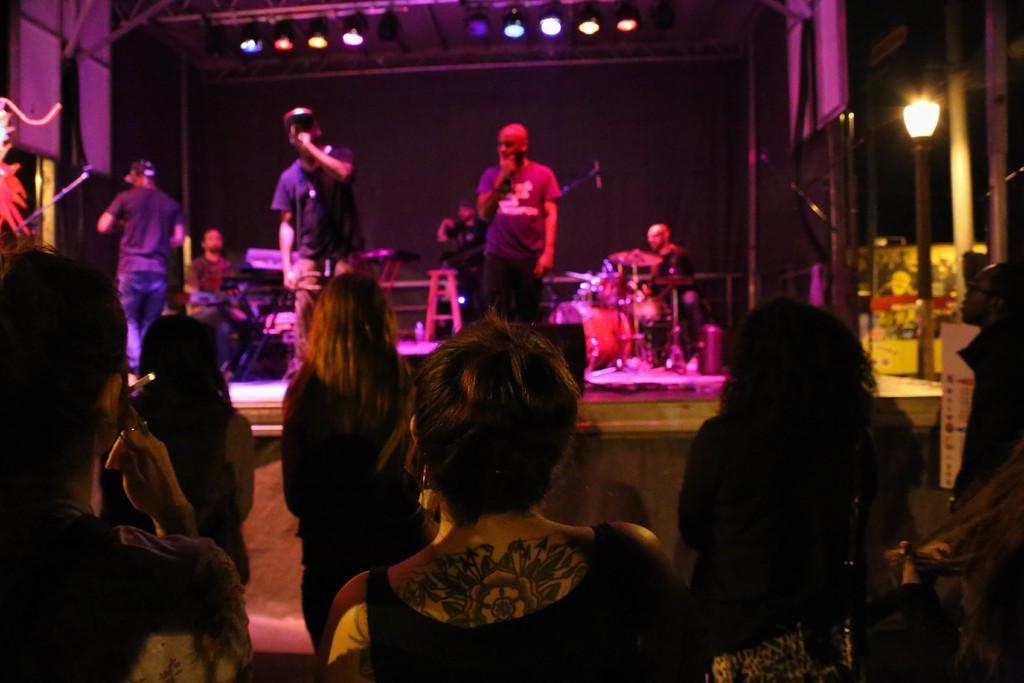Can you describe this image briefly? In this image I can see there are few persons standing in front of the stage , on the stage I can see there are few persons visible and I can see musical instruments on the stage ,at the top I can see lights visible. 